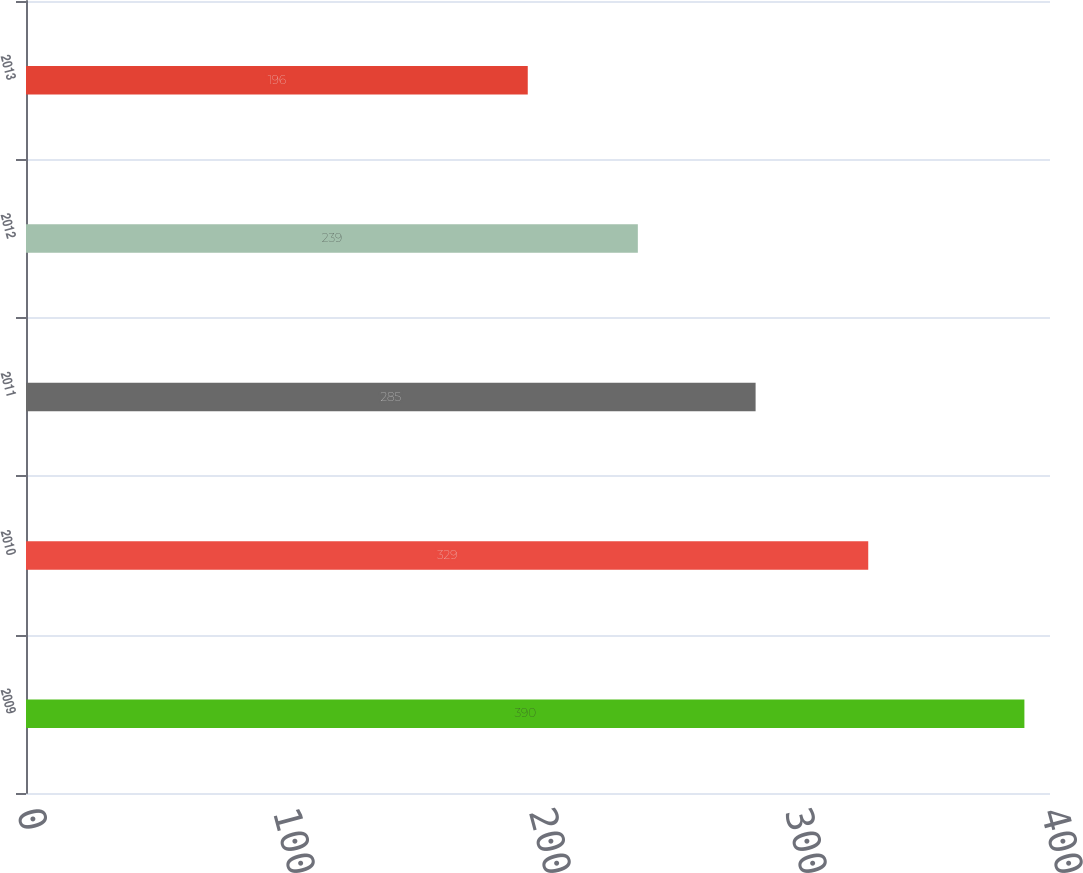Convert chart. <chart><loc_0><loc_0><loc_500><loc_500><bar_chart><fcel>2009<fcel>2010<fcel>2011<fcel>2012<fcel>2013<nl><fcel>390<fcel>329<fcel>285<fcel>239<fcel>196<nl></chart> 